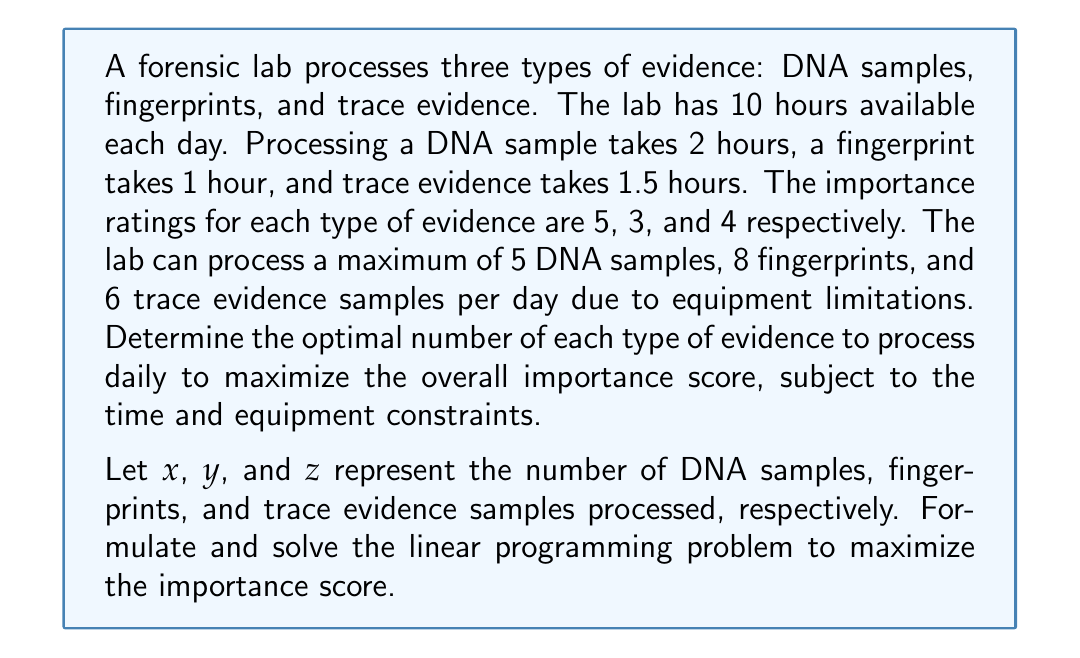Could you help me with this problem? To solve this optimization problem, we need to formulate it as a linear programming problem and then solve it.

1. Objective function:
   Maximize $f(x,y,z) = 5x + 3y + 4z$

2. Constraints:
   Time constraint: $2x + y + 1.5z \leq 10$
   Equipment constraints: $x \leq 5$, $y \leq 8$, $z \leq 6$
   Non-negativity: $x, y, z \geq 0$

3. Solving the linear programming problem:

   We can use the simplex method or a graphical method to solve this problem. Given the complexity, we'll use the simplex method.

   First, we introduce slack variables to convert inequalities to equations:
   $2x + y + 1.5z + s_1 = 10$
   $x + s_2 = 5$
   $y + s_3 = 8$
   $z + s_4 = 6$

   Initial simplex tableau:
   $$
   \begin{array}{c|cccccccc|c}
    & x & y & z & s_1 & s_2 & s_3 & s_4 & RHS \\
   \hline
   -f & -5 & -3 & -4 & 0 & 0 & 0 & 0 & 0 \\
   s_1 & 2 & 1 & 1.5 & 1 & 0 & 0 & 0 & 10 \\
   s_2 & 1 & 0 & 0 & 0 & 1 & 0 & 0 & 5 \\
   s_3 & 0 & 1 & 0 & 0 & 0 & 1 & 0 & 8 \\
   s_4 & 0 & 0 & 1 & 0 & 0 & 0 & 1 & 6 \\
   \end{array}
   $$

   After performing pivot operations, we reach the optimal solution:
   $$
   \begin{array}{c|cccccccc|c}
    & x & y & z & s_1 & s_2 & s_3 & s_4 & RHS \\
   \hline
   -f & 0 & 0 & 0 & 0.5 & 0 & 0 & 2.5 & 55 \\
   x & 1 & 0 & 0 & 0.5 & 1 & 0 & -0.5 & 5 \\
   y & 0 & 1 & 0 & 0 & 0 & 1 & 0 & 8 \\
   z & 0 & 0 & 1 & -0.5 & 0 & 0 & 1.5 & 4 \\
   s_1 & 0 & 0 & 0 & -0.5 & -2 & 0 & 1.5 & 0 \\
   \end{array}
   $$

4. Interpreting the results:
   The optimal solution is $x = 5$, $y = 8$, and $z = 4$.
   The maximum importance score is 55.
Answer: The optimal number of evidence samples to process daily is:
DNA samples (x): 5
Fingerprints (y): 8
Trace evidence (z): 4
Maximum importance score: 55 